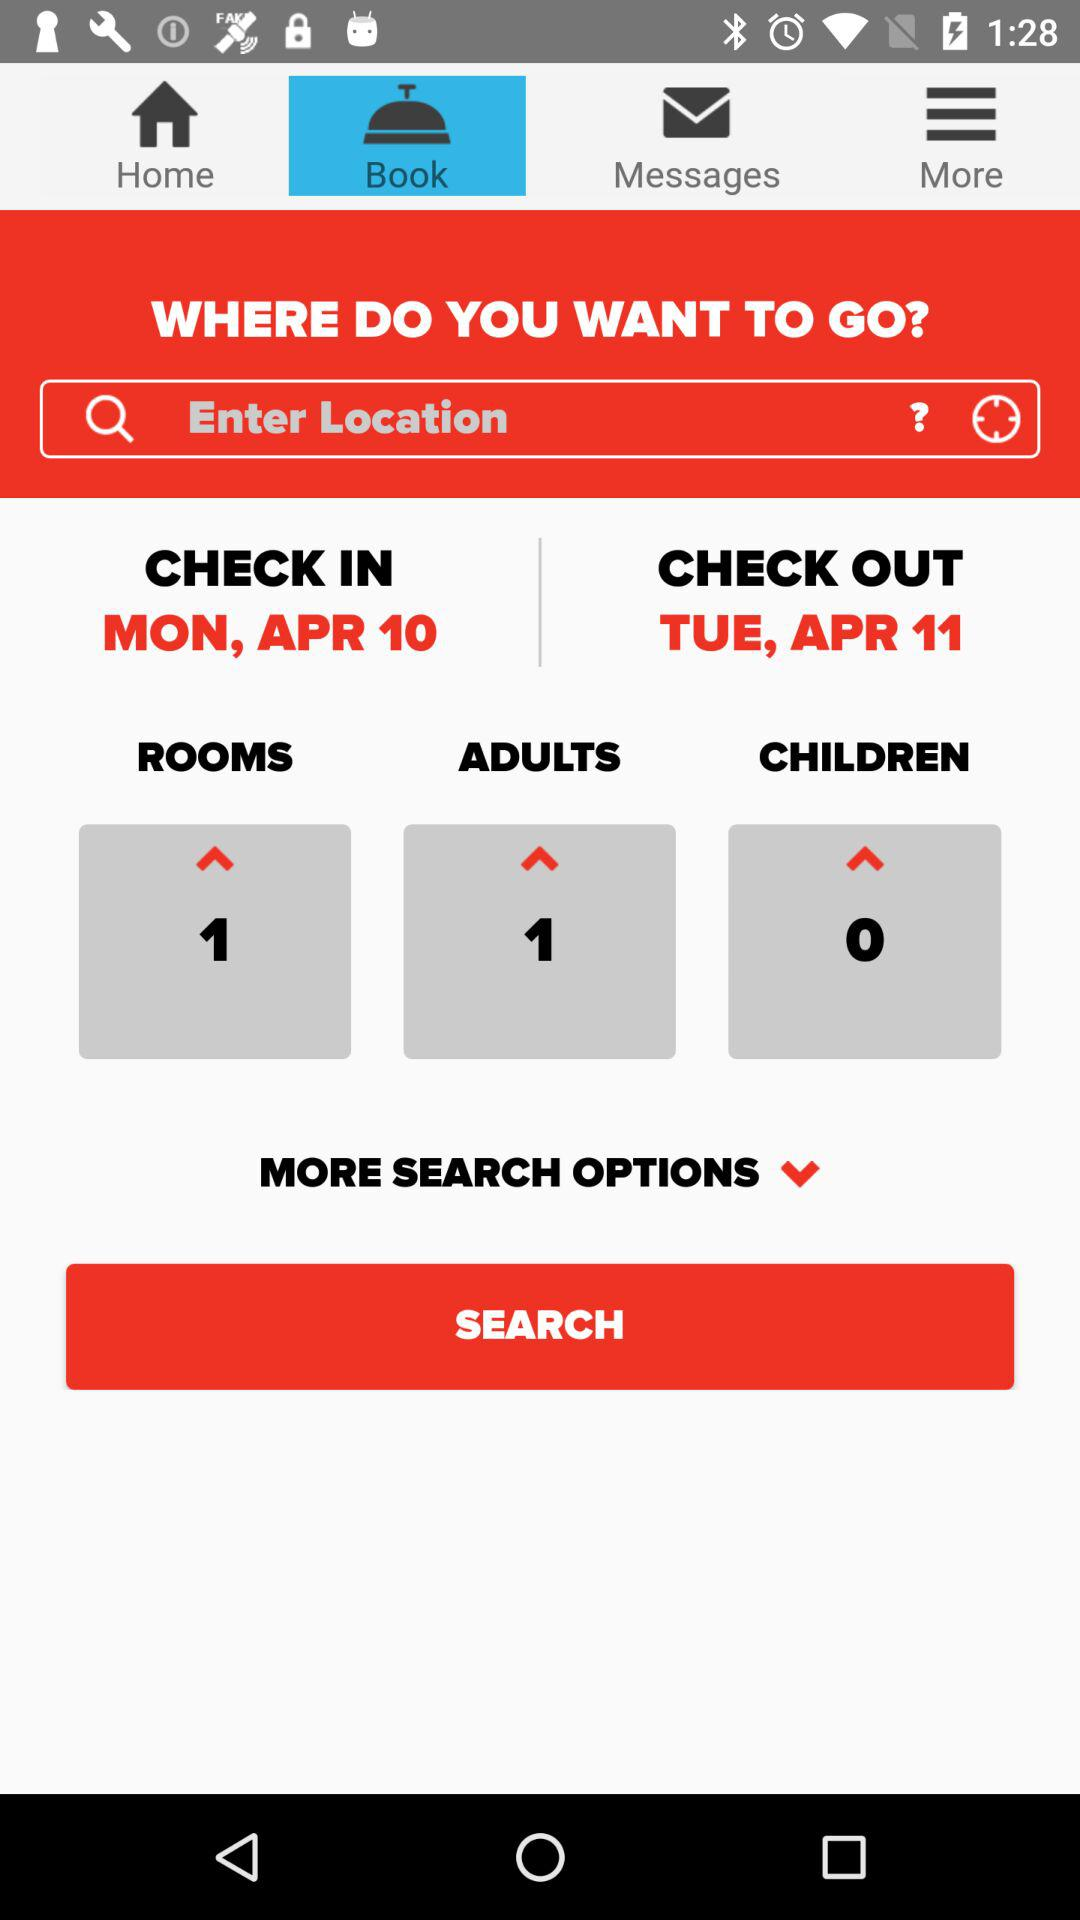What is the check-out date? The check-out date is Tuesday, April 11. 